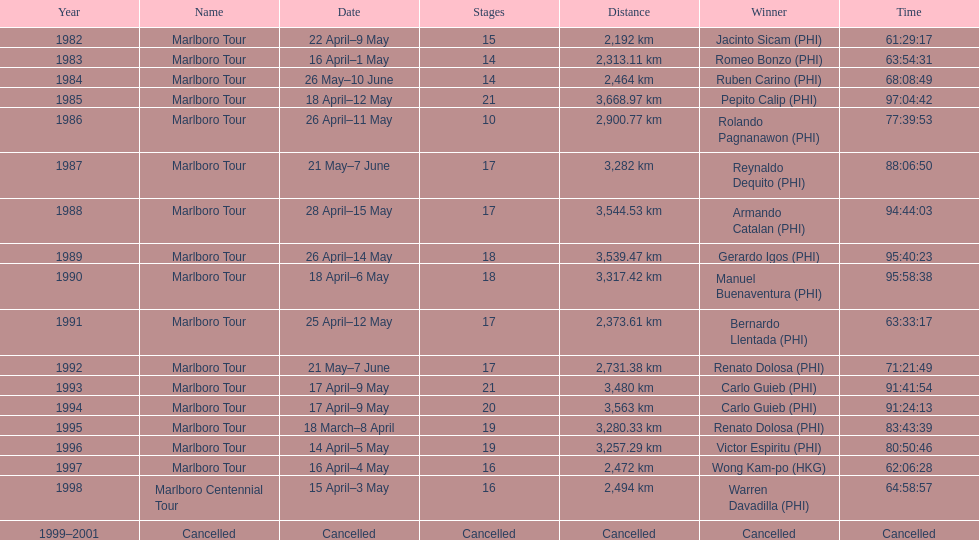Who secured the most victories in marlboro tours? Carlo Guieb. 